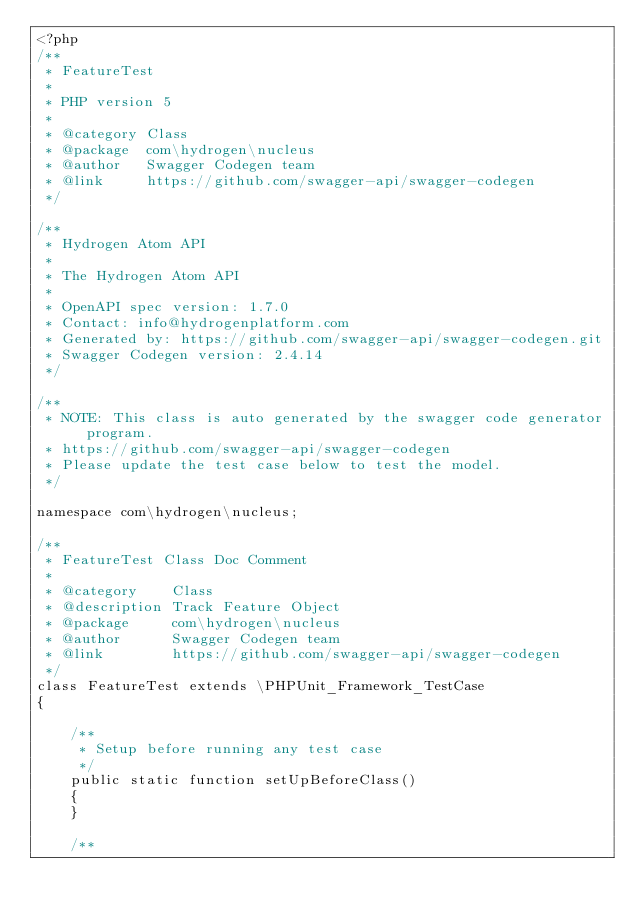Convert code to text. <code><loc_0><loc_0><loc_500><loc_500><_PHP_><?php
/**
 * FeatureTest
 *
 * PHP version 5
 *
 * @category Class
 * @package  com\hydrogen\nucleus
 * @author   Swagger Codegen team
 * @link     https://github.com/swagger-api/swagger-codegen
 */

/**
 * Hydrogen Atom API
 *
 * The Hydrogen Atom API
 *
 * OpenAPI spec version: 1.7.0
 * Contact: info@hydrogenplatform.com
 * Generated by: https://github.com/swagger-api/swagger-codegen.git
 * Swagger Codegen version: 2.4.14
 */

/**
 * NOTE: This class is auto generated by the swagger code generator program.
 * https://github.com/swagger-api/swagger-codegen
 * Please update the test case below to test the model.
 */

namespace com\hydrogen\nucleus;

/**
 * FeatureTest Class Doc Comment
 *
 * @category    Class
 * @description Track Feature Object
 * @package     com\hydrogen\nucleus
 * @author      Swagger Codegen team
 * @link        https://github.com/swagger-api/swagger-codegen
 */
class FeatureTest extends \PHPUnit_Framework_TestCase
{

    /**
     * Setup before running any test case
     */
    public static function setUpBeforeClass()
    {
    }

    /**</code> 